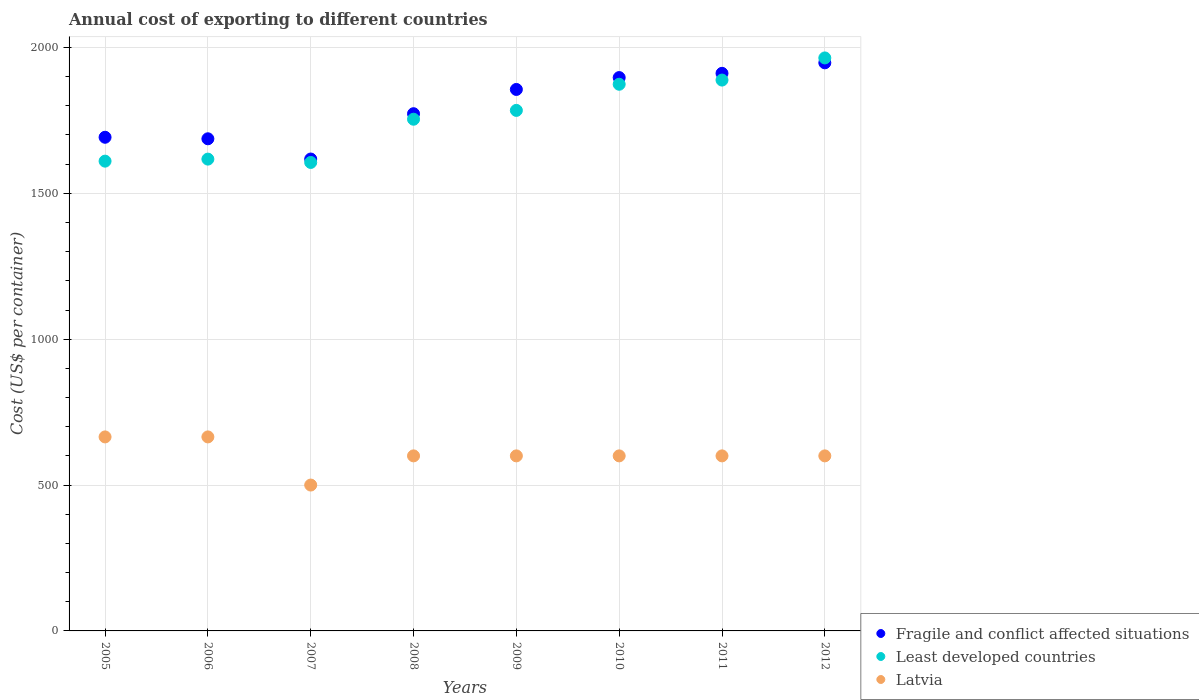How many different coloured dotlines are there?
Provide a short and direct response. 3. What is the total annual cost of exporting in Latvia in 2011?
Your answer should be very brief. 600. Across all years, what is the maximum total annual cost of exporting in Least developed countries?
Offer a terse response. 1964.04. Across all years, what is the minimum total annual cost of exporting in Latvia?
Give a very brief answer. 500. In which year was the total annual cost of exporting in Fragile and conflict affected situations maximum?
Provide a succinct answer. 2012. In which year was the total annual cost of exporting in Least developed countries minimum?
Keep it short and to the point. 2007. What is the total total annual cost of exporting in Least developed countries in the graph?
Provide a short and direct response. 1.41e+04. What is the difference between the total annual cost of exporting in Latvia in 2006 and that in 2011?
Ensure brevity in your answer.  65. What is the difference between the total annual cost of exporting in Latvia in 2009 and the total annual cost of exporting in Least developed countries in 2008?
Ensure brevity in your answer.  -1153.95. What is the average total annual cost of exporting in Least developed countries per year?
Make the answer very short. 1762.18. In the year 2010, what is the difference between the total annual cost of exporting in Fragile and conflict affected situations and total annual cost of exporting in Latvia?
Provide a short and direct response. 1296.7. What is the ratio of the total annual cost of exporting in Least developed countries in 2005 to that in 2009?
Ensure brevity in your answer.  0.9. Is the total annual cost of exporting in Least developed countries in 2006 less than that in 2008?
Ensure brevity in your answer.  Yes. Is the difference between the total annual cost of exporting in Fragile and conflict affected situations in 2009 and 2012 greater than the difference between the total annual cost of exporting in Latvia in 2009 and 2012?
Keep it short and to the point. No. What is the difference between the highest and the second highest total annual cost of exporting in Least developed countries?
Provide a succinct answer. 75.91. What is the difference between the highest and the lowest total annual cost of exporting in Latvia?
Make the answer very short. 165. Is the sum of the total annual cost of exporting in Fragile and conflict affected situations in 2010 and 2011 greater than the maximum total annual cost of exporting in Latvia across all years?
Your response must be concise. Yes. How many dotlines are there?
Make the answer very short. 3. Where does the legend appear in the graph?
Your answer should be compact. Bottom right. How many legend labels are there?
Your response must be concise. 3. What is the title of the graph?
Provide a short and direct response. Annual cost of exporting to different countries. What is the label or title of the X-axis?
Provide a short and direct response. Years. What is the label or title of the Y-axis?
Provide a short and direct response. Cost (US$ per container). What is the Cost (US$ per container) of Fragile and conflict affected situations in 2005?
Your answer should be compact. 1692.11. What is the Cost (US$ per container) of Least developed countries in 2005?
Your answer should be compact. 1610.26. What is the Cost (US$ per container) in Latvia in 2005?
Give a very brief answer. 665. What is the Cost (US$ per container) of Fragile and conflict affected situations in 2006?
Your answer should be compact. 1686.9. What is the Cost (US$ per container) in Least developed countries in 2006?
Offer a terse response. 1617.23. What is the Cost (US$ per container) in Latvia in 2006?
Provide a short and direct response. 665. What is the Cost (US$ per container) of Fragile and conflict affected situations in 2007?
Make the answer very short. 1617.52. What is the Cost (US$ per container) in Least developed countries in 2007?
Keep it short and to the point. 1605.8. What is the Cost (US$ per container) in Fragile and conflict affected situations in 2008?
Provide a short and direct response. 1772.86. What is the Cost (US$ per container) in Least developed countries in 2008?
Your response must be concise. 1753.95. What is the Cost (US$ per container) of Latvia in 2008?
Ensure brevity in your answer.  600. What is the Cost (US$ per container) of Fragile and conflict affected situations in 2009?
Provide a short and direct response. 1856. What is the Cost (US$ per container) of Least developed countries in 2009?
Make the answer very short. 1784.2. What is the Cost (US$ per container) of Latvia in 2009?
Your response must be concise. 600. What is the Cost (US$ per container) in Fragile and conflict affected situations in 2010?
Keep it short and to the point. 1896.7. What is the Cost (US$ per container) in Least developed countries in 2010?
Ensure brevity in your answer.  1873.82. What is the Cost (US$ per container) of Latvia in 2010?
Provide a short and direct response. 600. What is the Cost (US$ per container) in Fragile and conflict affected situations in 2011?
Make the answer very short. 1911.23. What is the Cost (US$ per container) of Least developed countries in 2011?
Your answer should be very brief. 1888.14. What is the Cost (US$ per container) in Latvia in 2011?
Offer a terse response. 600. What is the Cost (US$ per container) in Fragile and conflict affected situations in 2012?
Your answer should be compact. 1947.27. What is the Cost (US$ per container) in Least developed countries in 2012?
Keep it short and to the point. 1964.04. What is the Cost (US$ per container) in Latvia in 2012?
Your answer should be compact. 600. Across all years, what is the maximum Cost (US$ per container) of Fragile and conflict affected situations?
Offer a terse response. 1947.27. Across all years, what is the maximum Cost (US$ per container) of Least developed countries?
Ensure brevity in your answer.  1964.04. Across all years, what is the maximum Cost (US$ per container) in Latvia?
Your answer should be very brief. 665. Across all years, what is the minimum Cost (US$ per container) in Fragile and conflict affected situations?
Your answer should be compact. 1617.52. Across all years, what is the minimum Cost (US$ per container) of Least developed countries?
Offer a terse response. 1605.8. Across all years, what is the minimum Cost (US$ per container) of Latvia?
Offer a terse response. 500. What is the total Cost (US$ per container) of Fragile and conflict affected situations in the graph?
Your answer should be compact. 1.44e+04. What is the total Cost (US$ per container) in Least developed countries in the graph?
Your answer should be compact. 1.41e+04. What is the total Cost (US$ per container) in Latvia in the graph?
Keep it short and to the point. 4830. What is the difference between the Cost (US$ per container) in Fragile and conflict affected situations in 2005 and that in 2006?
Give a very brief answer. 5.21. What is the difference between the Cost (US$ per container) of Least developed countries in 2005 and that in 2006?
Make the answer very short. -6.97. What is the difference between the Cost (US$ per container) of Fragile and conflict affected situations in 2005 and that in 2007?
Offer a very short reply. 74.59. What is the difference between the Cost (US$ per container) of Least developed countries in 2005 and that in 2007?
Ensure brevity in your answer.  4.46. What is the difference between the Cost (US$ per container) of Latvia in 2005 and that in 2007?
Ensure brevity in your answer.  165. What is the difference between the Cost (US$ per container) in Fragile and conflict affected situations in 2005 and that in 2008?
Provide a succinct answer. -80.75. What is the difference between the Cost (US$ per container) in Least developed countries in 2005 and that in 2008?
Your answer should be very brief. -143.7. What is the difference between the Cost (US$ per container) of Fragile and conflict affected situations in 2005 and that in 2009?
Make the answer very short. -163.89. What is the difference between the Cost (US$ per container) of Least developed countries in 2005 and that in 2009?
Offer a terse response. -173.95. What is the difference between the Cost (US$ per container) in Fragile and conflict affected situations in 2005 and that in 2010?
Your response must be concise. -204.59. What is the difference between the Cost (US$ per container) in Least developed countries in 2005 and that in 2010?
Your answer should be compact. -263.56. What is the difference between the Cost (US$ per container) of Latvia in 2005 and that in 2010?
Your answer should be very brief. 65. What is the difference between the Cost (US$ per container) of Fragile and conflict affected situations in 2005 and that in 2011?
Make the answer very short. -219.13. What is the difference between the Cost (US$ per container) in Least developed countries in 2005 and that in 2011?
Give a very brief answer. -277.88. What is the difference between the Cost (US$ per container) of Latvia in 2005 and that in 2011?
Give a very brief answer. 65. What is the difference between the Cost (US$ per container) of Fragile and conflict affected situations in 2005 and that in 2012?
Give a very brief answer. -255.17. What is the difference between the Cost (US$ per container) of Least developed countries in 2005 and that in 2012?
Offer a terse response. -353.79. What is the difference between the Cost (US$ per container) of Fragile and conflict affected situations in 2006 and that in 2007?
Ensure brevity in your answer.  69.38. What is the difference between the Cost (US$ per container) in Least developed countries in 2006 and that in 2007?
Provide a short and direct response. 11.43. What is the difference between the Cost (US$ per container) in Latvia in 2006 and that in 2007?
Your answer should be compact. 165. What is the difference between the Cost (US$ per container) of Fragile and conflict affected situations in 2006 and that in 2008?
Offer a terse response. -85.97. What is the difference between the Cost (US$ per container) in Least developed countries in 2006 and that in 2008?
Your answer should be compact. -136.73. What is the difference between the Cost (US$ per container) of Latvia in 2006 and that in 2008?
Provide a short and direct response. 65. What is the difference between the Cost (US$ per container) of Fragile and conflict affected situations in 2006 and that in 2009?
Ensure brevity in your answer.  -169.1. What is the difference between the Cost (US$ per container) of Least developed countries in 2006 and that in 2009?
Offer a very short reply. -166.98. What is the difference between the Cost (US$ per container) of Fragile and conflict affected situations in 2006 and that in 2010?
Your response must be concise. -209.8. What is the difference between the Cost (US$ per container) of Least developed countries in 2006 and that in 2010?
Provide a succinct answer. -256.59. What is the difference between the Cost (US$ per container) of Latvia in 2006 and that in 2010?
Ensure brevity in your answer.  65. What is the difference between the Cost (US$ per container) in Fragile and conflict affected situations in 2006 and that in 2011?
Ensure brevity in your answer.  -224.34. What is the difference between the Cost (US$ per container) of Least developed countries in 2006 and that in 2011?
Your response must be concise. -270.91. What is the difference between the Cost (US$ per container) in Latvia in 2006 and that in 2011?
Provide a succinct answer. 65. What is the difference between the Cost (US$ per container) of Fragile and conflict affected situations in 2006 and that in 2012?
Offer a terse response. -260.38. What is the difference between the Cost (US$ per container) of Least developed countries in 2006 and that in 2012?
Offer a very short reply. -346.82. What is the difference between the Cost (US$ per container) of Fragile and conflict affected situations in 2007 and that in 2008?
Ensure brevity in your answer.  -155.34. What is the difference between the Cost (US$ per container) in Least developed countries in 2007 and that in 2008?
Offer a very short reply. -148.16. What is the difference between the Cost (US$ per container) of Latvia in 2007 and that in 2008?
Your answer should be very brief. -100. What is the difference between the Cost (US$ per container) of Fragile and conflict affected situations in 2007 and that in 2009?
Provide a short and direct response. -238.48. What is the difference between the Cost (US$ per container) of Least developed countries in 2007 and that in 2009?
Your answer should be very brief. -178.41. What is the difference between the Cost (US$ per container) of Latvia in 2007 and that in 2009?
Your response must be concise. -100. What is the difference between the Cost (US$ per container) of Fragile and conflict affected situations in 2007 and that in 2010?
Your answer should be very brief. -279.18. What is the difference between the Cost (US$ per container) of Least developed countries in 2007 and that in 2010?
Ensure brevity in your answer.  -268.02. What is the difference between the Cost (US$ per container) in Latvia in 2007 and that in 2010?
Provide a short and direct response. -100. What is the difference between the Cost (US$ per container) in Fragile and conflict affected situations in 2007 and that in 2011?
Provide a succinct answer. -293.72. What is the difference between the Cost (US$ per container) in Least developed countries in 2007 and that in 2011?
Provide a succinct answer. -282.34. What is the difference between the Cost (US$ per container) in Latvia in 2007 and that in 2011?
Keep it short and to the point. -100. What is the difference between the Cost (US$ per container) in Fragile and conflict affected situations in 2007 and that in 2012?
Offer a very short reply. -329.76. What is the difference between the Cost (US$ per container) in Least developed countries in 2007 and that in 2012?
Provide a succinct answer. -358.25. What is the difference between the Cost (US$ per container) in Latvia in 2007 and that in 2012?
Your answer should be very brief. -100. What is the difference between the Cost (US$ per container) in Fragile and conflict affected situations in 2008 and that in 2009?
Offer a terse response. -83.14. What is the difference between the Cost (US$ per container) of Least developed countries in 2008 and that in 2009?
Offer a terse response. -30.25. What is the difference between the Cost (US$ per container) in Fragile and conflict affected situations in 2008 and that in 2010?
Offer a very short reply. -123.84. What is the difference between the Cost (US$ per container) in Least developed countries in 2008 and that in 2010?
Ensure brevity in your answer.  -119.86. What is the difference between the Cost (US$ per container) of Fragile and conflict affected situations in 2008 and that in 2011?
Offer a terse response. -138.37. What is the difference between the Cost (US$ per container) in Least developed countries in 2008 and that in 2011?
Give a very brief answer. -134.18. What is the difference between the Cost (US$ per container) of Fragile and conflict affected situations in 2008 and that in 2012?
Your answer should be very brief. -174.41. What is the difference between the Cost (US$ per container) in Least developed countries in 2008 and that in 2012?
Offer a very short reply. -210.09. What is the difference between the Cost (US$ per container) of Fragile and conflict affected situations in 2009 and that in 2010?
Provide a short and direct response. -40.7. What is the difference between the Cost (US$ per container) of Least developed countries in 2009 and that in 2010?
Give a very brief answer. -89.61. What is the difference between the Cost (US$ per container) of Fragile and conflict affected situations in 2009 and that in 2011?
Provide a succinct answer. -55.23. What is the difference between the Cost (US$ per container) of Least developed countries in 2009 and that in 2011?
Keep it short and to the point. -103.93. What is the difference between the Cost (US$ per container) of Latvia in 2009 and that in 2011?
Your answer should be compact. 0. What is the difference between the Cost (US$ per container) of Fragile and conflict affected situations in 2009 and that in 2012?
Offer a terse response. -91.27. What is the difference between the Cost (US$ per container) of Least developed countries in 2009 and that in 2012?
Keep it short and to the point. -179.84. What is the difference between the Cost (US$ per container) of Latvia in 2009 and that in 2012?
Provide a short and direct response. 0. What is the difference between the Cost (US$ per container) in Fragile and conflict affected situations in 2010 and that in 2011?
Provide a short and direct response. -14.53. What is the difference between the Cost (US$ per container) of Least developed countries in 2010 and that in 2011?
Provide a succinct answer. -14.32. What is the difference between the Cost (US$ per container) in Fragile and conflict affected situations in 2010 and that in 2012?
Keep it short and to the point. -50.57. What is the difference between the Cost (US$ per container) in Least developed countries in 2010 and that in 2012?
Offer a very short reply. -90.23. What is the difference between the Cost (US$ per container) of Fragile and conflict affected situations in 2011 and that in 2012?
Offer a terse response. -36.04. What is the difference between the Cost (US$ per container) of Least developed countries in 2011 and that in 2012?
Make the answer very short. -75.91. What is the difference between the Cost (US$ per container) in Fragile and conflict affected situations in 2005 and the Cost (US$ per container) in Least developed countries in 2006?
Your response must be concise. 74.88. What is the difference between the Cost (US$ per container) of Fragile and conflict affected situations in 2005 and the Cost (US$ per container) of Latvia in 2006?
Provide a short and direct response. 1027.11. What is the difference between the Cost (US$ per container) of Least developed countries in 2005 and the Cost (US$ per container) of Latvia in 2006?
Provide a succinct answer. 945.26. What is the difference between the Cost (US$ per container) of Fragile and conflict affected situations in 2005 and the Cost (US$ per container) of Least developed countries in 2007?
Provide a succinct answer. 86.31. What is the difference between the Cost (US$ per container) of Fragile and conflict affected situations in 2005 and the Cost (US$ per container) of Latvia in 2007?
Provide a short and direct response. 1192.11. What is the difference between the Cost (US$ per container) of Least developed countries in 2005 and the Cost (US$ per container) of Latvia in 2007?
Ensure brevity in your answer.  1110.26. What is the difference between the Cost (US$ per container) in Fragile and conflict affected situations in 2005 and the Cost (US$ per container) in Least developed countries in 2008?
Give a very brief answer. -61.85. What is the difference between the Cost (US$ per container) of Fragile and conflict affected situations in 2005 and the Cost (US$ per container) of Latvia in 2008?
Give a very brief answer. 1092.11. What is the difference between the Cost (US$ per container) of Least developed countries in 2005 and the Cost (US$ per container) of Latvia in 2008?
Offer a terse response. 1010.26. What is the difference between the Cost (US$ per container) in Fragile and conflict affected situations in 2005 and the Cost (US$ per container) in Least developed countries in 2009?
Provide a succinct answer. -92.1. What is the difference between the Cost (US$ per container) of Fragile and conflict affected situations in 2005 and the Cost (US$ per container) of Latvia in 2009?
Your answer should be compact. 1092.11. What is the difference between the Cost (US$ per container) in Least developed countries in 2005 and the Cost (US$ per container) in Latvia in 2009?
Your answer should be very brief. 1010.26. What is the difference between the Cost (US$ per container) of Fragile and conflict affected situations in 2005 and the Cost (US$ per container) of Least developed countries in 2010?
Make the answer very short. -181.71. What is the difference between the Cost (US$ per container) in Fragile and conflict affected situations in 2005 and the Cost (US$ per container) in Latvia in 2010?
Offer a terse response. 1092.11. What is the difference between the Cost (US$ per container) of Least developed countries in 2005 and the Cost (US$ per container) of Latvia in 2010?
Provide a succinct answer. 1010.26. What is the difference between the Cost (US$ per container) of Fragile and conflict affected situations in 2005 and the Cost (US$ per container) of Least developed countries in 2011?
Ensure brevity in your answer.  -196.03. What is the difference between the Cost (US$ per container) in Fragile and conflict affected situations in 2005 and the Cost (US$ per container) in Latvia in 2011?
Your response must be concise. 1092.11. What is the difference between the Cost (US$ per container) of Least developed countries in 2005 and the Cost (US$ per container) of Latvia in 2011?
Provide a succinct answer. 1010.26. What is the difference between the Cost (US$ per container) in Fragile and conflict affected situations in 2005 and the Cost (US$ per container) in Least developed countries in 2012?
Your answer should be compact. -271.94. What is the difference between the Cost (US$ per container) in Fragile and conflict affected situations in 2005 and the Cost (US$ per container) in Latvia in 2012?
Offer a very short reply. 1092.11. What is the difference between the Cost (US$ per container) in Least developed countries in 2005 and the Cost (US$ per container) in Latvia in 2012?
Your response must be concise. 1010.26. What is the difference between the Cost (US$ per container) of Fragile and conflict affected situations in 2006 and the Cost (US$ per container) of Least developed countries in 2007?
Provide a succinct answer. 81.1. What is the difference between the Cost (US$ per container) of Fragile and conflict affected situations in 2006 and the Cost (US$ per container) of Latvia in 2007?
Keep it short and to the point. 1186.9. What is the difference between the Cost (US$ per container) of Least developed countries in 2006 and the Cost (US$ per container) of Latvia in 2007?
Provide a succinct answer. 1117.23. What is the difference between the Cost (US$ per container) of Fragile and conflict affected situations in 2006 and the Cost (US$ per container) of Least developed countries in 2008?
Make the answer very short. -67.06. What is the difference between the Cost (US$ per container) in Fragile and conflict affected situations in 2006 and the Cost (US$ per container) in Latvia in 2008?
Make the answer very short. 1086.9. What is the difference between the Cost (US$ per container) in Least developed countries in 2006 and the Cost (US$ per container) in Latvia in 2008?
Make the answer very short. 1017.23. What is the difference between the Cost (US$ per container) in Fragile and conflict affected situations in 2006 and the Cost (US$ per container) in Least developed countries in 2009?
Your answer should be very brief. -97.31. What is the difference between the Cost (US$ per container) of Fragile and conflict affected situations in 2006 and the Cost (US$ per container) of Latvia in 2009?
Your answer should be very brief. 1086.9. What is the difference between the Cost (US$ per container) in Least developed countries in 2006 and the Cost (US$ per container) in Latvia in 2009?
Provide a succinct answer. 1017.23. What is the difference between the Cost (US$ per container) in Fragile and conflict affected situations in 2006 and the Cost (US$ per container) in Least developed countries in 2010?
Keep it short and to the point. -186.92. What is the difference between the Cost (US$ per container) of Fragile and conflict affected situations in 2006 and the Cost (US$ per container) of Latvia in 2010?
Provide a short and direct response. 1086.9. What is the difference between the Cost (US$ per container) of Least developed countries in 2006 and the Cost (US$ per container) of Latvia in 2010?
Give a very brief answer. 1017.23. What is the difference between the Cost (US$ per container) in Fragile and conflict affected situations in 2006 and the Cost (US$ per container) in Least developed countries in 2011?
Give a very brief answer. -201.24. What is the difference between the Cost (US$ per container) of Fragile and conflict affected situations in 2006 and the Cost (US$ per container) of Latvia in 2011?
Offer a terse response. 1086.9. What is the difference between the Cost (US$ per container) of Least developed countries in 2006 and the Cost (US$ per container) of Latvia in 2011?
Your response must be concise. 1017.23. What is the difference between the Cost (US$ per container) in Fragile and conflict affected situations in 2006 and the Cost (US$ per container) in Least developed countries in 2012?
Your answer should be very brief. -277.15. What is the difference between the Cost (US$ per container) of Fragile and conflict affected situations in 2006 and the Cost (US$ per container) of Latvia in 2012?
Ensure brevity in your answer.  1086.9. What is the difference between the Cost (US$ per container) of Least developed countries in 2006 and the Cost (US$ per container) of Latvia in 2012?
Your answer should be compact. 1017.23. What is the difference between the Cost (US$ per container) of Fragile and conflict affected situations in 2007 and the Cost (US$ per container) of Least developed countries in 2008?
Offer a very short reply. -136.44. What is the difference between the Cost (US$ per container) of Fragile and conflict affected situations in 2007 and the Cost (US$ per container) of Latvia in 2008?
Make the answer very short. 1017.52. What is the difference between the Cost (US$ per container) of Least developed countries in 2007 and the Cost (US$ per container) of Latvia in 2008?
Your answer should be compact. 1005.8. What is the difference between the Cost (US$ per container) in Fragile and conflict affected situations in 2007 and the Cost (US$ per container) in Least developed countries in 2009?
Keep it short and to the point. -166.69. What is the difference between the Cost (US$ per container) of Fragile and conflict affected situations in 2007 and the Cost (US$ per container) of Latvia in 2009?
Ensure brevity in your answer.  1017.52. What is the difference between the Cost (US$ per container) in Least developed countries in 2007 and the Cost (US$ per container) in Latvia in 2009?
Ensure brevity in your answer.  1005.8. What is the difference between the Cost (US$ per container) in Fragile and conflict affected situations in 2007 and the Cost (US$ per container) in Least developed countries in 2010?
Your answer should be compact. -256.3. What is the difference between the Cost (US$ per container) of Fragile and conflict affected situations in 2007 and the Cost (US$ per container) of Latvia in 2010?
Provide a short and direct response. 1017.52. What is the difference between the Cost (US$ per container) of Least developed countries in 2007 and the Cost (US$ per container) of Latvia in 2010?
Offer a very short reply. 1005.8. What is the difference between the Cost (US$ per container) in Fragile and conflict affected situations in 2007 and the Cost (US$ per container) in Least developed countries in 2011?
Offer a terse response. -270.62. What is the difference between the Cost (US$ per container) in Fragile and conflict affected situations in 2007 and the Cost (US$ per container) in Latvia in 2011?
Provide a succinct answer. 1017.52. What is the difference between the Cost (US$ per container) in Least developed countries in 2007 and the Cost (US$ per container) in Latvia in 2011?
Make the answer very short. 1005.8. What is the difference between the Cost (US$ per container) of Fragile and conflict affected situations in 2007 and the Cost (US$ per container) of Least developed countries in 2012?
Your response must be concise. -346.53. What is the difference between the Cost (US$ per container) in Fragile and conflict affected situations in 2007 and the Cost (US$ per container) in Latvia in 2012?
Keep it short and to the point. 1017.52. What is the difference between the Cost (US$ per container) in Least developed countries in 2007 and the Cost (US$ per container) in Latvia in 2012?
Keep it short and to the point. 1005.8. What is the difference between the Cost (US$ per container) of Fragile and conflict affected situations in 2008 and the Cost (US$ per container) of Least developed countries in 2009?
Provide a short and direct response. -11.34. What is the difference between the Cost (US$ per container) in Fragile and conflict affected situations in 2008 and the Cost (US$ per container) in Latvia in 2009?
Provide a succinct answer. 1172.86. What is the difference between the Cost (US$ per container) in Least developed countries in 2008 and the Cost (US$ per container) in Latvia in 2009?
Provide a succinct answer. 1153.95. What is the difference between the Cost (US$ per container) in Fragile and conflict affected situations in 2008 and the Cost (US$ per container) in Least developed countries in 2010?
Provide a short and direct response. -100.96. What is the difference between the Cost (US$ per container) of Fragile and conflict affected situations in 2008 and the Cost (US$ per container) of Latvia in 2010?
Your answer should be very brief. 1172.86. What is the difference between the Cost (US$ per container) in Least developed countries in 2008 and the Cost (US$ per container) in Latvia in 2010?
Provide a short and direct response. 1153.95. What is the difference between the Cost (US$ per container) in Fragile and conflict affected situations in 2008 and the Cost (US$ per container) in Least developed countries in 2011?
Offer a terse response. -115.27. What is the difference between the Cost (US$ per container) of Fragile and conflict affected situations in 2008 and the Cost (US$ per container) of Latvia in 2011?
Keep it short and to the point. 1172.86. What is the difference between the Cost (US$ per container) of Least developed countries in 2008 and the Cost (US$ per container) of Latvia in 2011?
Offer a very short reply. 1153.95. What is the difference between the Cost (US$ per container) of Fragile and conflict affected situations in 2008 and the Cost (US$ per container) of Least developed countries in 2012?
Give a very brief answer. -191.18. What is the difference between the Cost (US$ per container) in Fragile and conflict affected situations in 2008 and the Cost (US$ per container) in Latvia in 2012?
Your answer should be very brief. 1172.86. What is the difference between the Cost (US$ per container) of Least developed countries in 2008 and the Cost (US$ per container) of Latvia in 2012?
Provide a succinct answer. 1153.95. What is the difference between the Cost (US$ per container) in Fragile and conflict affected situations in 2009 and the Cost (US$ per container) in Least developed countries in 2010?
Your answer should be compact. -17.82. What is the difference between the Cost (US$ per container) in Fragile and conflict affected situations in 2009 and the Cost (US$ per container) in Latvia in 2010?
Ensure brevity in your answer.  1256. What is the difference between the Cost (US$ per container) in Least developed countries in 2009 and the Cost (US$ per container) in Latvia in 2010?
Your answer should be compact. 1184.2. What is the difference between the Cost (US$ per container) of Fragile and conflict affected situations in 2009 and the Cost (US$ per container) of Least developed countries in 2011?
Provide a succinct answer. -32.14. What is the difference between the Cost (US$ per container) in Fragile and conflict affected situations in 2009 and the Cost (US$ per container) in Latvia in 2011?
Make the answer very short. 1256. What is the difference between the Cost (US$ per container) in Least developed countries in 2009 and the Cost (US$ per container) in Latvia in 2011?
Offer a terse response. 1184.2. What is the difference between the Cost (US$ per container) of Fragile and conflict affected situations in 2009 and the Cost (US$ per container) of Least developed countries in 2012?
Provide a succinct answer. -108.04. What is the difference between the Cost (US$ per container) in Fragile and conflict affected situations in 2009 and the Cost (US$ per container) in Latvia in 2012?
Your answer should be very brief. 1256. What is the difference between the Cost (US$ per container) of Least developed countries in 2009 and the Cost (US$ per container) of Latvia in 2012?
Offer a very short reply. 1184.2. What is the difference between the Cost (US$ per container) in Fragile and conflict affected situations in 2010 and the Cost (US$ per container) in Least developed countries in 2011?
Ensure brevity in your answer.  8.56. What is the difference between the Cost (US$ per container) in Fragile and conflict affected situations in 2010 and the Cost (US$ per container) in Latvia in 2011?
Provide a succinct answer. 1296.7. What is the difference between the Cost (US$ per container) of Least developed countries in 2010 and the Cost (US$ per container) of Latvia in 2011?
Give a very brief answer. 1273.82. What is the difference between the Cost (US$ per container) of Fragile and conflict affected situations in 2010 and the Cost (US$ per container) of Least developed countries in 2012?
Your answer should be very brief. -67.34. What is the difference between the Cost (US$ per container) of Fragile and conflict affected situations in 2010 and the Cost (US$ per container) of Latvia in 2012?
Your answer should be compact. 1296.7. What is the difference between the Cost (US$ per container) in Least developed countries in 2010 and the Cost (US$ per container) in Latvia in 2012?
Give a very brief answer. 1273.82. What is the difference between the Cost (US$ per container) of Fragile and conflict affected situations in 2011 and the Cost (US$ per container) of Least developed countries in 2012?
Make the answer very short. -52.81. What is the difference between the Cost (US$ per container) of Fragile and conflict affected situations in 2011 and the Cost (US$ per container) of Latvia in 2012?
Keep it short and to the point. 1311.23. What is the difference between the Cost (US$ per container) in Least developed countries in 2011 and the Cost (US$ per container) in Latvia in 2012?
Your answer should be compact. 1288.14. What is the average Cost (US$ per container) in Fragile and conflict affected situations per year?
Provide a short and direct response. 1797.57. What is the average Cost (US$ per container) in Least developed countries per year?
Offer a very short reply. 1762.18. What is the average Cost (US$ per container) in Latvia per year?
Provide a succinct answer. 603.75. In the year 2005, what is the difference between the Cost (US$ per container) of Fragile and conflict affected situations and Cost (US$ per container) of Least developed countries?
Offer a very short reply. 81.85. In the year 2005, what is the difference between the Cost (US$ per container) of Fragile and conflict affected situations and Cost (US$ per container) of Latvia?
Provide a succinct answer. 1027.11. In the year 2005, what is the difference between the Cost (US$ per container) of Least developed countries and Cost (US$ per container) of Latvia?
Provide a short and direct response. 945.26. In the year 2006, what is the difference between the Cost (US$ per container) in Fragile and conflict affected situations and Cost (US$ per container) in Least developed countries?
Keep it short and to the point. 69.67. In the year 2006, what is the difference between the Cost (US$ per container) of Fragile and conflict affected situations and Cost (US$ per container) of Latvia?
Your answer should be compact. 1021.9. In the year 2006, what is the difference between the Cost (US$ per container) of Least developed countries and Cost (US$ per container) of Latvia?
Offer a terse response. 952.23. In the year 2007, what is the difference between the Cost (US$ per container) in Fragile and conflict affected situations and Cost (US$ per container) in Least developed countries?
Keep it short and to the point. 11.72. In the year 2007, what is the difference between the Cost (US$ per container) of Fragile and conflict affected situations and Cost (US$ per container) of Latvia?
Ensure brevity in your answer.  1117.52. In the year 2007, what is the difference between the Cost (US$ per container) of Least developed countries and Cost (US$ per container) of Latvia?
Ensure brevity in your answer.  1105.8. In the year 2008, what is the difference between the Cost (US$ per container) of Fragile and conflict affected situations and Cost (US$ per container) of Least developed countries?
Provide a short and direct response. 18.91. In the year 2008, what is the difference between the Cost (US$ per container) of Fragile and conflict affected situations and Cost (US$ per container) of Latvia?
Give a very brief answer. 1172.86. In the year 2008, what is the difference between the Cost (US$ per container) in Least developed countries and Cost (US$ per container) in Latvia?
Make the answer very short. 1153.95. In the year 2009, what is the difference between the Cost (US$ per container) in Fragile and conflict affected situations and Cost (US$ per container) in Least developed countries?
Your answer should be very brief. 71.8. In the year 2009, what is the difference between the Cost (US$ per container) in Fragile and conflict affected situations and Cost (US$ per container) in Latvia?
Provide a short and direct response. 1256. In the year 2009, what is the difference between the Cost (US$ per container) of Least developed countries and Cost (US$ per container) of Latvia?
Provide a short and direct response. 1184.2. In the year 2010, what is the difference between the Cost (US$ per container) of Fragile and conflict affected situations and Cost (US$ per container) of Least developed countries?
Make the answer very short. 22.88. In the year 2010, what is the difference between the Cost (US$ per container) in Fragile and conflict affected situations and Cost (US$ per container) in Latvia?
Keep it short and to the point. 1296.7. In the year 2010, what is the difference between the Cost (US$ per container) of Least developed countries and Cost (US$ per container) of Latvia?
Ensure brevity in your answer.  1273.82. In the year 2011, what is the difference between the Cost (US$ per container) in Fragile and conflict affected situations and Cost (US$ per container) in Least developed countries?
Offer a very short reply. 23.1. In the year 2011, what is the difference between the Cost (US$ per container) in Fragile and conflict affected situations and Cost (US$ per container) in Latvia?
Offer a very short reply. 1311.23. In the year 2011, what is the difference between the Cost (US$ per container) of Least developed countries and Cost (US$ per container) of Latvia?
Make the answer very short. 1288.14. In the year 2012, what is the difference between the Cost (US$ per container) of Fragile and conflict affected situations and Cost (US$ per container) of Least developed countries?
Keep it short and to the point. -16.77. In the year 2012, what is the difference between the Cost (US$ per container) in Fragile and conflict affected situations and Cost (US$ per container) in Latvia?
Your answer should be very brief. 1347.27. In the year 2012, what is the difference between the Cost (US$ per container) in Least developed countries and Cost (US$ per container) in Latvia?
Provide a short and direct response. 1364.04. What is the ratio of the Cost (US$ per container) of Latvia in 2005 to that in 2006?
Provide a succinct answer. 1. What is the ratio of the Cost (US$ per container) in Fragile and conflict affected situations in 2005 to that in 2007?
Provide a short and direct response. 1.05. What is the ratio of the Cost (US$ per container) in Latvia in 2005 to that in 2007?
Keep it short and to the point. 1.33. What is the ratio of the Cost (US$ per container) in Fragile and conflict affected situations in 2005 to that in 2008?
Your answer should be very brief. 0.95. What is the ratio of the Cost (US$ per container) of Least developed countries in 2005 to that in 2008?
Your answer should be very brief. 0.92. What is the ratio of the Cost (US$ per container) in Latvia in 2005 to that in 2008?
Make the answer very short. 1.11. What is the ratio of the Cost (US$ per container) in Fragile and conflict affected situations in 2005 to that in 2009?
Offer a very short reply. 0.91. What is the ratio of the Cost (US$ per container) of Least developed countries in 2005 to that in 2009?
Your answer should be very brief. 0.9. What is the ratio of the Cost (US$ per container) in Latvia in 2005 to that in 2009?
Your answer should be compact. 1.11. What is the ratio of the Cost (US$ per container) in Fragile and conflict affected situations in 2005 to that in 2010?
Offer a very short reply. 0.89. What is the ratio of the Cost (US$ per container) in Least developed countries in 2005 to that in 2010?
Keep it short and to the point. 0.86. What is the ratio of the Cost (US$ per container) of Latvia in 2005 to that in 2010?
Offer a very short reply. 1.11. What is the ratio of the Cost (US$ per container) of Fragile and conflict affected situations in 2005 to that in 2011?
Your response must be concise. 0.89. What is the ratio of the Cost (US$ per container) in Least developed countries in 2005 to that in 2011?
Make the answer very short. 0.85. What is the ratio of the Cost (US$ per container) in Latvia in 2005 to that in 2011?
Provide a short and direct response. 1.11. What is the ratio of the Cost (US$ per container) in Fragile and conflict affected situations in 2005 to that in 2012?
Your response must be concise. 0.87. What is the ratio of the Cost (US$ per container) in Least developed countries in 2005 to that in 2012?
Make the answer very short. 0.82. What is the ratio of the Cost (US$ per container) of Latvia in 2005 to that in 2012?
Offer a terse response. 1.11. What is the ratio of the Cost (US$ per container) in Fragile and conflict affected situations in 2006 to that in 2007?
Your answer should be very brief. 1.04. What is the ratio of the Cost (US$ per container) of Least developed countries in 2006 to that in 2007?
Offer a very short reply. 1.01. What is the ratio of the Cost (US$ per container) of Latvia in 2006 to that in 2007?
Offer a very short reply. 1.33. What is the ratio of the Cost (US$ per container) of Fragile and conflict affected situations in 2006 to that in 2008?
Offer a terse response. 0.95. What is the ratio of the Cost (US$ per container) in Least developed countries in 2006 to that in 2008?
Your answer should be very brief. 0.92. What is the ratio of the Cost (US$ per container) of Latvia in 2006 to that in 2008?
Make the answer very short. 1.11. What is the ratio of the Cost (US$ per container) of Fragile and conflict affected situations in 2006 to that in 2009?
Offer a terse response. 0.91. What is the ratio of the Cost (US$ per container) of Least developed countries in 2006 to that in 2009?
Offer a terse response. 0.91. What is the ratio of the Cost (US$ per container) of Latvia in 2006 to that in 2009?
Your response must be concise. 1.11. What is the ratio of the Cost (US$ per container) of Fragile and conflict affected situations in 2006 to that in 2010?
Your response must be concise. 0.89. What is the ratio of the Cost (US$ per container) of Least developed countries in 2006 to that in 2010?
Your response must be concise. 0.86. What is the ratio of the Cost (US$ per container) in Latvia in 2006 to that in 2010?
Offer a very short reply. 1.11. What is the ratio of the Cost (US$ per container) in Fragile and conflict affected situations in 2006 to that in 2011?
Offer a terse response. 0.88. What is the ratio of the Cost (US$ per container) in Least developed countries in 2006 to that in 2011?
Provide a succinct answer. 0.86. What is the ratio of the Cost (US$ per container) in Latvia in 2006 to that in 2011?
Provide a short and direct response. 1.11. What is the ratio of the Cost (US$ per container) of Fragile and conflict affected situations in 2006 to that in 2012?
Give a very brief answer. 0.87. What is the ratio of the Cost (US$ per container) of Least developed countries in 2006 to that in 2012?
Provide a short and direct response. 0.82. What is the ratio of the Cost (US$ per container) of Latvia in 2006 to that in 2012?
Keep it short and to the point. 1.11. What is the ratio of the Cost (US$ per container) of Fragile and conflict affected situations in 2007 to that in 2008?
Your response must be concise. 0.91. What is the ratio of the Cost (US$ per container) of Least developed countries in 2007 to that in 2008?
Ensure brevity in your answer.  0.92. What is the ratio of the Cost (US$ per container) in Latvia in 2007 to that in 2008?
Give a very brief answer. 0.83. What is the ratio of the Cost (US$ per container) in Fragile and conflict affected situations in 2007 to that in 2009?
Keep it short and to the point. 0.87. What is the ratio of the Cost (US$ per container) in Least developed countries in 2007 to that in 2009?
Offer a very short reply. 0.9. What is the ratio of the Cost (US$ per container) in Latvia in 2007 to that in 2009?
Offer a terse response. 0.83. What is the ratio of the Cost (US$ per container) of Fragile and conflict affected situations in 2007 to that in 2010?
Your response must be concise. 0.85. What is the ratio of the Cost (US$ per container) in Least developed countries in 2007 to that in 2010?
Offer a terse response. 0.86. What is the ratio of the Cost (US$ per container) of Latvia in 2007 to that in 2010?
Give a very brief answer. 0.83. What is the ratio of the Cost (US$ per container) in Fragile and conflict affected situations in 2007 to that in 2011?
Offer a very short reply. 0.85. What is the ratio of the Cost (US$ per container) of Least developed countries in 2007 to that in 2011?
Offer a terse response. 0.85. What is the ratio of the Cost (US$ per container) of Latvia in 2007 to that in 2011?
Offer a terse response. 0.83. What is the ratio of the Cost (US$ per container) of Fragile and conflict affected situations in 2007 to that in 2012?
Provide a succinct answer. 0.83. What is the ratio of the Cost (US$ per container) of Least developed countries in 2007 to that in 2012?
Keep it short and to the point. 0.82. What is the ratio of the Cost (US$ per container) of Fragile and conflict affected situations in 2008 to that in 2009?
Your answer should be very brief. 0.96. What is the ratio of the Cost (US$ per container) of Fragile and conflict affected situations in 2008 to that in 2010?
Give a very brief answer. 0.93. What is the ratio of the Cost (US$ per container) of Least developed countries in 2008 to that in 2010?
Offer a terse response. 0.94. What is the ratio of the Cost (US$ per container) in Latvia in 2008 to that in 2010?
Your response must be concise. 1. What is the ratio of the Cost (US$ per container) of Fragile and conflict affected situations in 2008 to that in 2011?
Make the answer very short. 0.93. What is the ratio of the Cost (US$ per container) of Least developed countries in 2008 to that in 2011?
Your answer should be compact. 0.93. What is the ratio of the Cost (US$ per container) in Fragile and conflict affected situations in 2008 to that in 2012?
Keep it short and to the point. 0.91. What is the ratio of the Cost (US$ per container) in Least developed countries in 2008 to that in 2012?
Provide a short and direct response. 0.89. What is the ratio of the Cost (US$ per container) in Latvia in 2008 to that in 2012?
Provide a succinct answer. 1. What is the ratio of the Cost (US$ per container) in Fragile and conflict affected situations in 2009 to that in 2010?
Keep it short and to the point. 0.98. What is the ratio of the Cost (US$ per container) of Least developed countries in 2009 to that in 2010?
Keep it short and to the point. 0.95. What is the ratio of the Cost (US$ per container) in Fragile and conflict affected situations in 2009 to that in 2011?
Offer a terse response. 0.97. What is the ratio of the Cost (US$ per container) in Least developed countries in 2009 to that in 2011?
Make the answer very short. 0.94. What is the ratio of the Cost (US$ per container) of Latvia in 2009 to that in 2011?
Give a very brief answer. 1. What is the ratio of the Cost (US$ per container) of Fragile and conflict affected situations in 2009 to that in 2012?
Ensure brevity in your answer.  0.95. What is the ratio of the Cost (US$ per container) of Least developed countries in 2009 to that in 2012?
Your response must be concise. 0.91. What is the ratio of the Cost (US$ per container) of Latvia in 2010 to that in 2011?
Your answer should be compact. 1. What is the ratio of the Cost (US$ per container) in Fragile and conflict affected situations in 2010 to that in 2012?
Offer a terse response. 0.97. What is the ratio of the Cost (US$ per container) in Least developed countries in 2010 to that in 2012?
Provide a short and direct response. 0.95. What is the ratio of the Cost (US$ per container) of Latvia in 2010 to that in 2012?
Your answer should be compact. 1. What is the ratio of the Cost (US$ per container) in Fragile and conflict affected situations in 2011 to that in 2012?
Your answer should be compact. 0.98. What is the ratio of the Cost (US$ per container) in Least developed countries in 2011 to that in 2012?
Keep it short and to the point. 0.96. What is the difference between the highest and the second highest Cost (US$ per container) of Fragile and conflict affected situations?
Keep it short and to the point. 36.04. What is the difference between the highest and the second highest Cost (US$ per container) in Least developed countries?
Offer a very short reply. 75.91. What is the difference between the highest and the lowest Cost (US$ per container) of Fragile and conflict affected situations?
Give a very brief answer. 329.76. What is the difference between the highest and the lowest Cost (US$ per container) in Least developed countries?
Offer a very short reply. 358.25. What is the difference between the highest and the lowest Cost (US$ per container) of Latvia?
Your response must be concise. 165. 